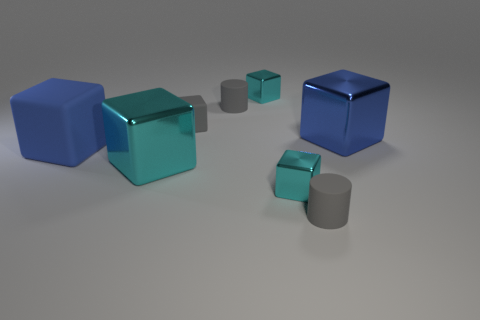There is a matte cylinder in front of the large blue metal object; how many blue shiny things are to the left of it?
Your answer should be very brief. 0. There is a shiny object that is the same size as the blue metal cube; what color is it?
Make the answer very short. Cyan. There is a cylinder in front of the tiny gray rubber block; what material is it?
Ensure brevity in your answer.  Rubber. What is the material of the tiny gray thing that is on the right side of the tiny gray cube and behind the blue rubber block?
Provide a succinct answer. Rubber. There is a gray cube that is behind the blue matte thing; does it have the same size as the blue matte thing?
Your response must be concise. No. There is a blue shiny thing; what shape is it?
Keep it short and to the point. Cube. How many tiny gray matte things are the same shape as the big blue matte object?
Ensure brevity in your answer.  1. How many large blue things are both in front of the large blue shiny cube and right of the big matte cube?
Your answer should be compact. 0. What is the color of the tiny rubber cube?
Make the answer very short. Gray. Is there a gray thing that has the same material as the large cyan thing?
Offer a terse response. No. 